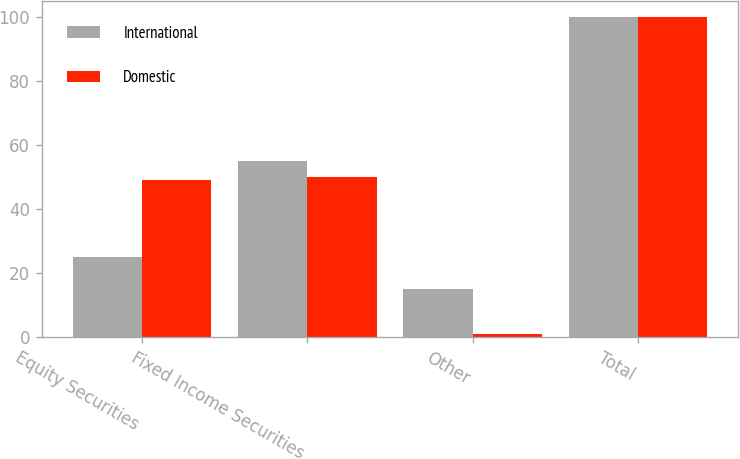Convert chart. <chart><loc_0><loc_0><loc_500><loc_500><stacked_bar_chart><ecel><fcel>Equity Securities<fcel>Fixed Income Securities<fcel>Other<fcel>Total<nl><fcel>International<fcel>25<fcel>55<fcel>15<fcel>100<nl><fcel>Domestic<fcel>49<fcel>50<fcel>1<fcel>100<nl></chart> 